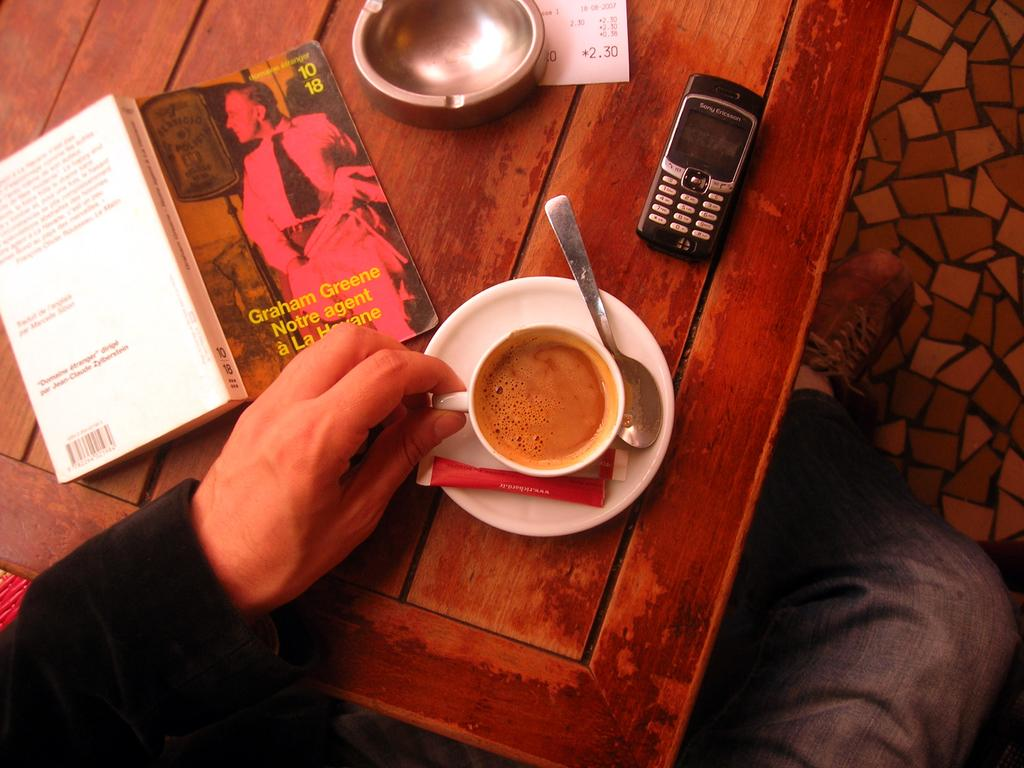What is the person in the image holding? The person is holding a cup in the image. What can be seen on the table in the image? There is a table in the image, and a mobile is visible on it. What else is present on the table? There is a book on the table in the image. What is in the cup that the person is holding? There is a cup with coffee in the image. What type of lunch is the robin eating in the image? There is no robin or lunch present in the image. How does the person in the image feel about their crush? There is no information about the person's feelings towards a crush in the image. 